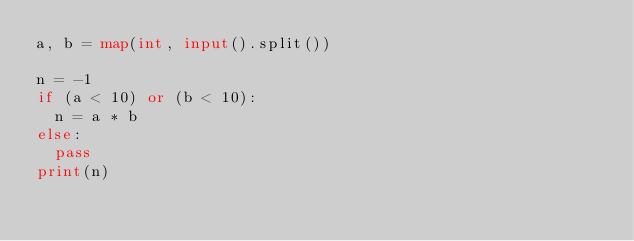Convert code to text. <code><loc_0><loc_0><loc_500><loc_500><_Python_>a, b = map(int, input().split())

n = -1
if (a < 10) or (b < 10):
  n = a * b
else:
  pass
print(n)</code> 